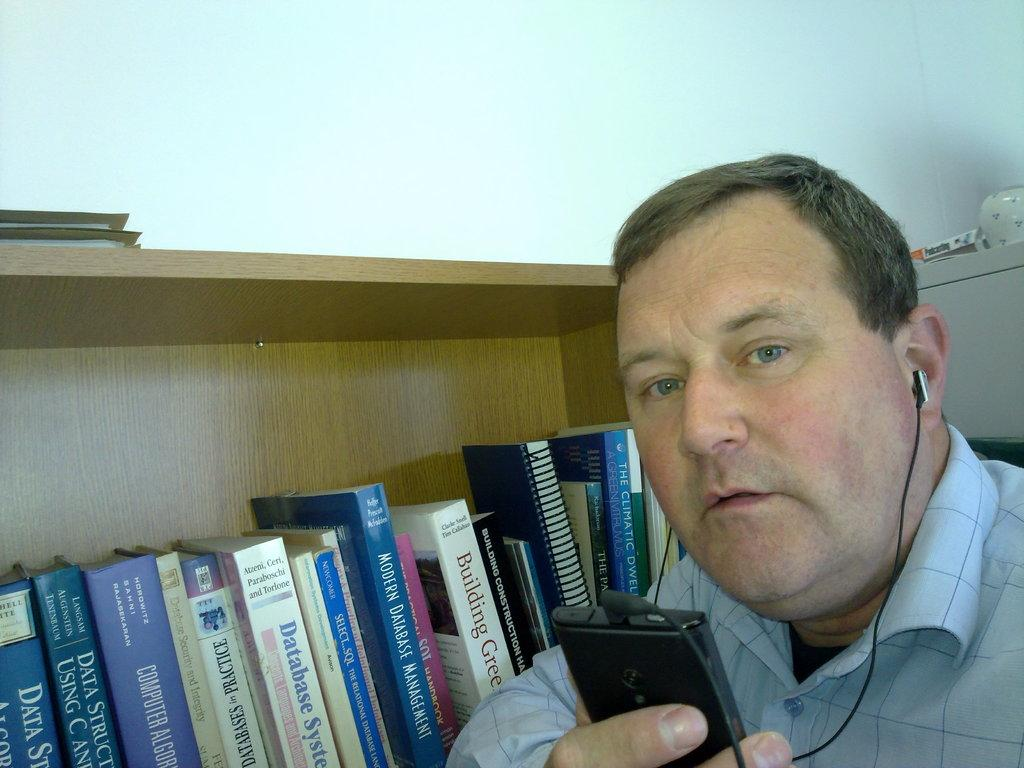<image>
Give a short and clear explanation of the subsequent image. A man uses his phone next to a shelf with books on database management and database systems. 